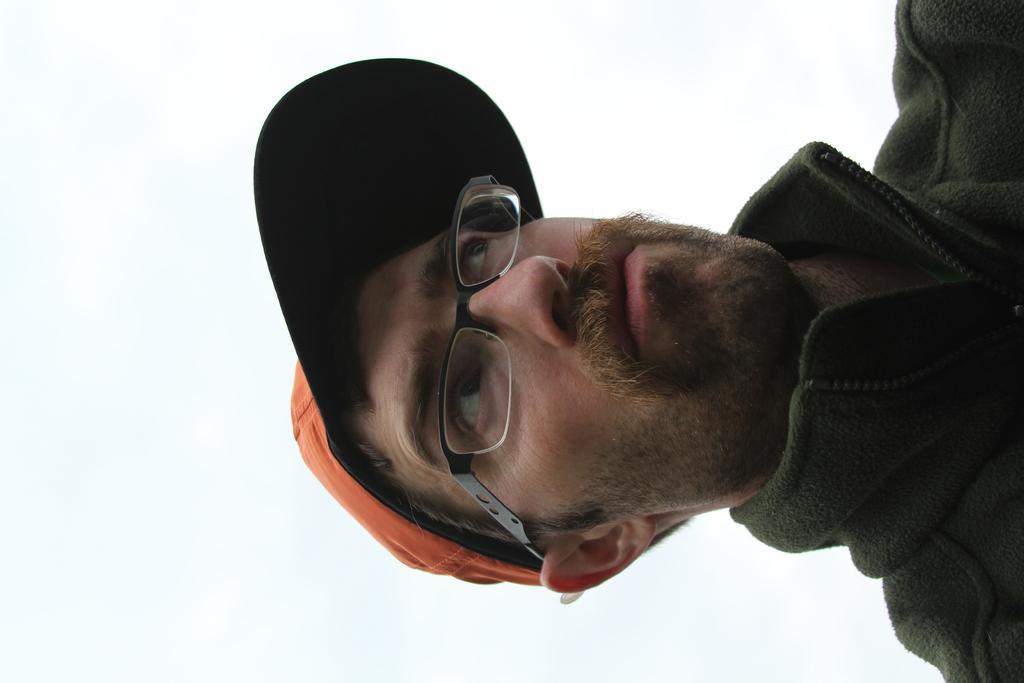In one or two sentences, can you explain what this image depicts? In the center of the image there is a person wearing a orange color cap and a jacket. 